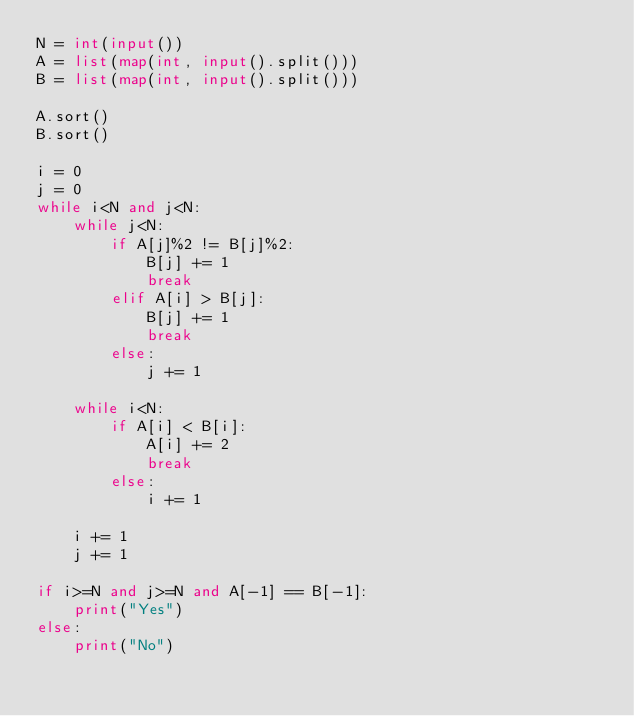<code> <loc_0><loc_0><loc_500><loc_500><_Python_>N = int(input())
A = list(map(int, input().split()))
B = list(map(int, input().split()))

A.sort()
B.sort()

i = 0
j = 0
while i<N and j<N:
    while j<N:
        if A[j]%2 != B[j]%2:
            B[j] += 1
            break
        elif A[i] > B[j]:
            B[j] += 1
            break
        else:
            j += 1

    while i<N:
        if A[i] < B[i]:
            A[i] += 2
            break
        else:
            i += 1
    
    i += 1
    j += 1

if i>=N and j>=N and A[-1] == B[-1]:
    print("Yes")
else:
    print("No")</code> 